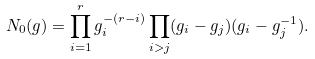<formula> <loc_0><loc_0><loc_500><loc_500>N _ { 0 } ( g ) = \prod _ { i = 1 } ^ { r } g _ { i } ^ { - ( r - i ) } \prod _ { i > j } ( g _ { i } - g _ { j } ) ( g _ { i } - g _ { j } ^ { - 1 } ) .</formula> 